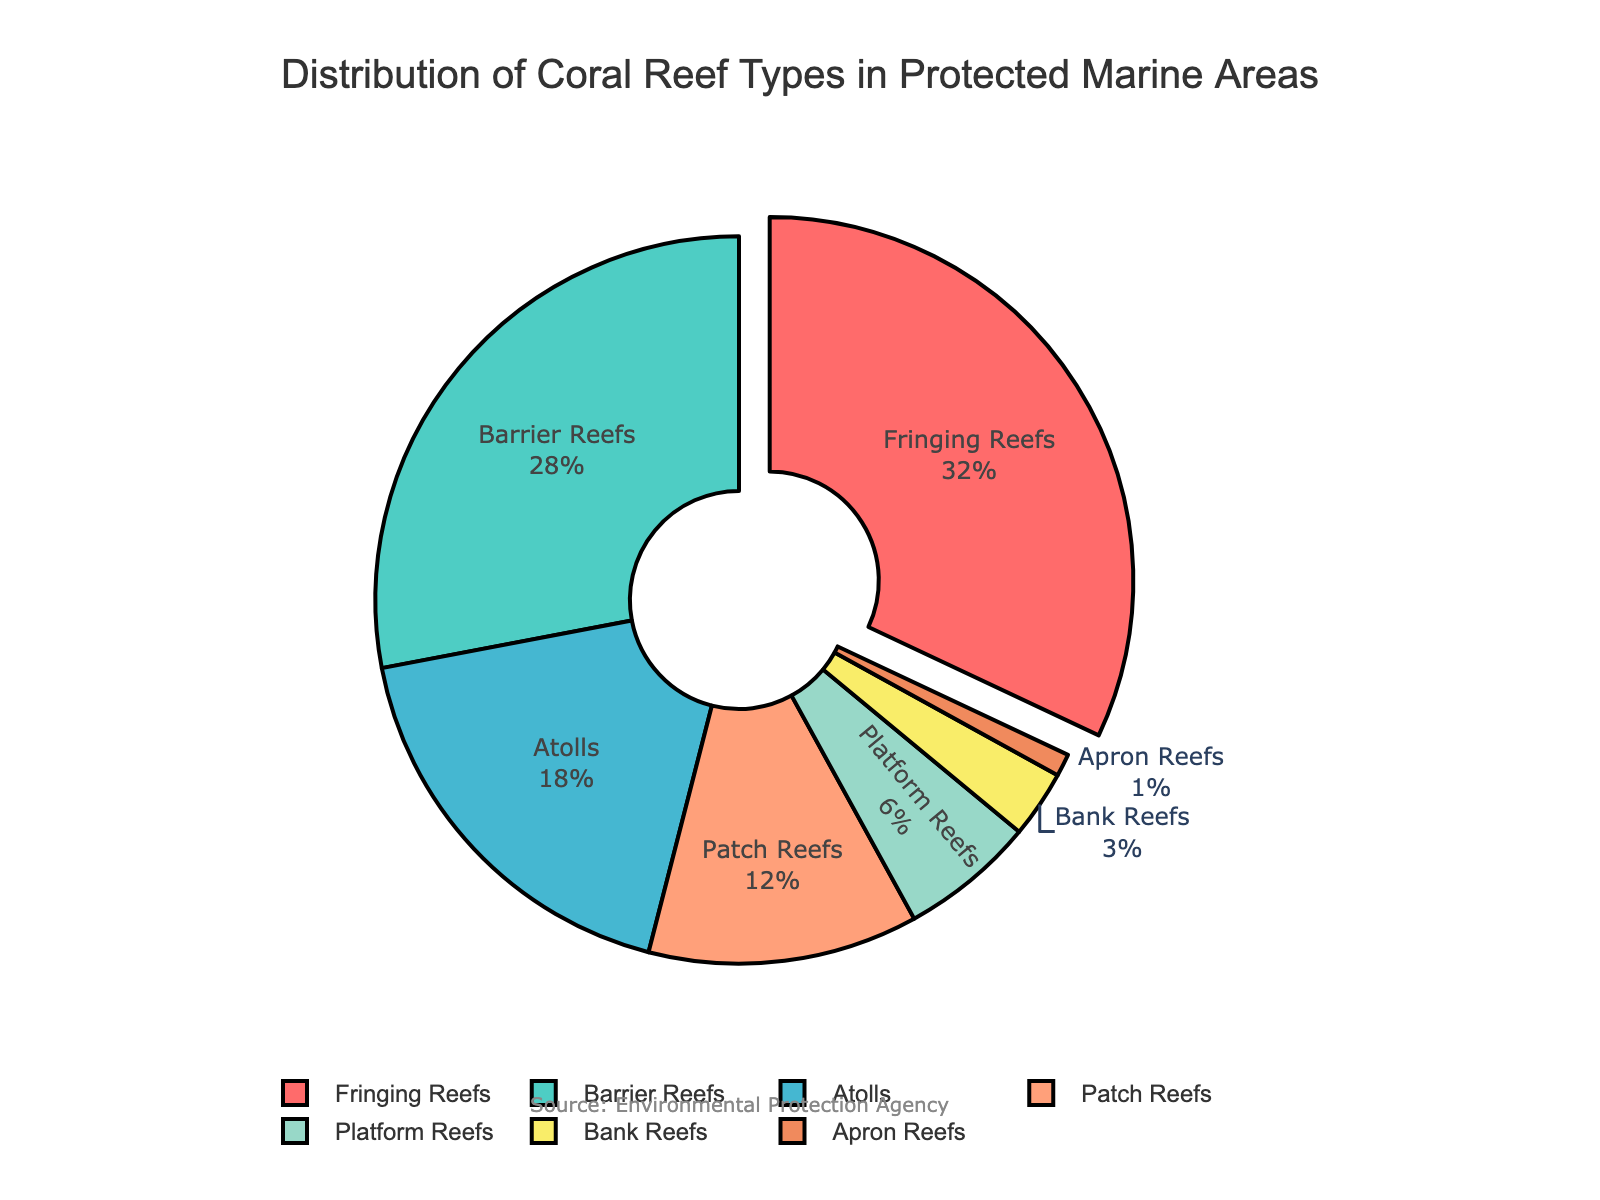Which reef type occupies the largest percentage of protected marine areas? The figure indicates that "Fringing Reefs" occupy the largest percentage of protected marine areas as they are pulled out from the pie and have the highest percentage value listed.
Answer: Fringing Reefs Which two reef types combined make up more than 50% of the protected marine areas? To answer this, we need to add the percentages of the reef types. Fringing Reefs (32%) and Barrier Reefs (28%) together make up 32% + 28% = 60%, which is more than 50%.
Answer: Fringing Reefs and Barrier Reefs Which reef type is the least represented in protected marine areas? The figure shows that "Apron Reefs" have the smallest segment with only 1% of the total.
Answer: Apron Reefs What is the total percentage of Atolls and Patch Reefs combined? Add the percentages of both Atolls (18%) and Patch Reefs (12%). 18% + 12% = 30%.
Answer: 30% How much larger is the percentage of Fringing Reefs compared to Platform Reefs in protected marine areas? Subtract the percentage of Platform Reefs (6%) from the percentage of Fringing Reefs (32%) to find the difference: 32% - 6% = 26%.
Answer: 26% If you combine the three least represented reef types, what percentage of protected marine areas do they make up? By adding the percentages of Bank Reefs (3%), Platform Reefs (6%), and Apron Reefs (1%), we get 3% + 6% + 1% = 10%.
Answer: 10% Which reef type has a higher percentage, Barrier Reefs or Atolls? Compare the percentages: Barrier Reefs have 28% and Atolls have 18%, so Barrier Reefs have a higher percentage.
Answer: Barrier Reefs What is the sum of the percentages for Patch Reefs, Platform Reefs, and Bank Reefs? Add the percentages of Patch Reefs (12%), Platform Reefs (6%), and Bank Reefs (3%) together: 12% + 6% + 3% = 21%.
Answer: 21% What percentage of the protected marine areas is made up of reef types that individually constitute less than 10%? The qualifying reef types are Patch Reefs (12%), Platform Reefs (6%), Bank Reefs (3%), and Apron Reefs (1%). Adding them up: 6% + 3% + 1% = 10% (since Patch Reefs have more than 10%, they are excluded).
Answer: 10% Among the reef types visualized, which one is represented by a green segment in the pie chart? According to the color scheme mentioned, "Barrier Reefs" are represented in green.
Answer: Barrier Reefs 